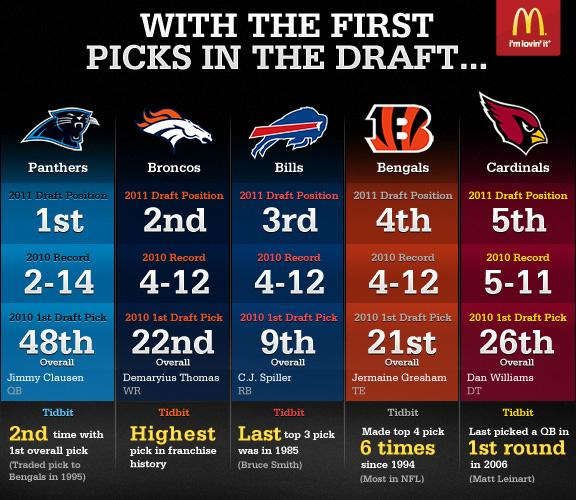Point out several critical features in this image. In 2010, three teams had a record of 4-12. 